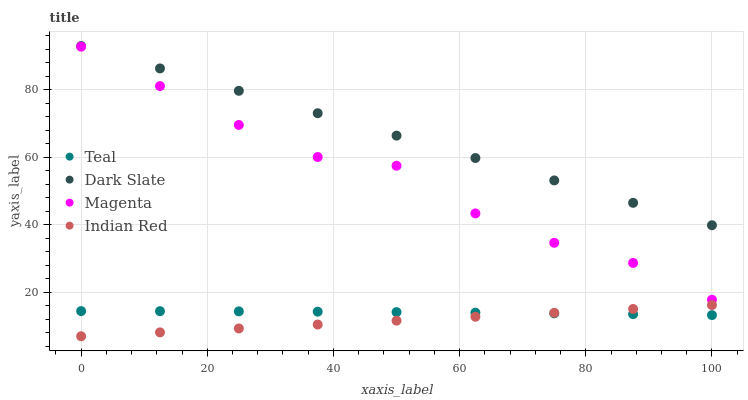Does Indian Red have the minimum area under the curve?
Answer yes or no. Yes. Does Dark Slate have the maximum area under the curve?
Answer yes or no. Yes. Does Magenta have the minimum area under the curve?
Answer yes or no. No. Does Magenta have the maximum area under the curve?
Answer yes or no. No. Is Indian Red the smoothest?
Answer yes or no. Yes. Is Magenta the roughest?
Answer yes or no. Yes. Is Magenta the smoothest?
Answer yes or no. No. Is Indian Red the roughest?
Answer yes or no. No. Does Indian Red have the lowest value?
Answer yes or no. Yes. Does Magenta have the lowest value?
Answer yes or no. No. Does Dark Slate have the highest value?
Answer yes or no. Yes. Does Magenta have the highest value?
Answer yes or no. No. Is Magenta less than Dark Slate?
Answer yes or no. Yes. Is Dark Slate greater than Magenta?
Answer yes or no. Yes. Does Teal intersect Indian Red?
Answer yes or no. Yes. Is Teal less than Indian Red?
Answer yes or no. No. Is Teal greater than Indian Red?
Answer yes or no. No. Does Magenta intersect Dark Slate?
Answer yes or no. No. 